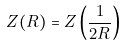<formula> <loc_0><loc_0><loc_500><loc_500>Z ( R ) = Z \left ( \frac { 1 } { 2 R } \right )</formula> 